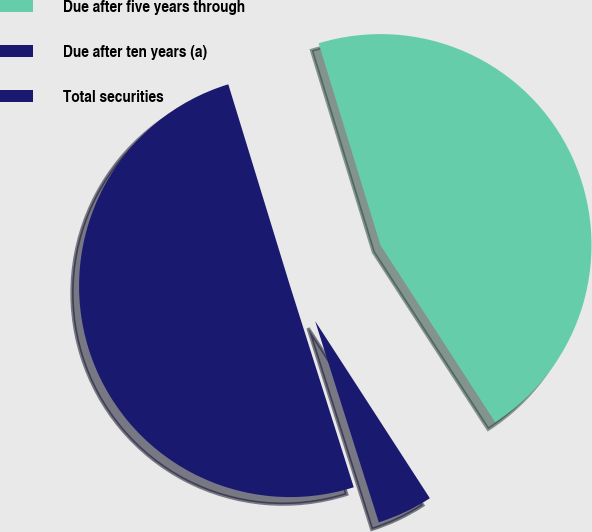<chart> <loc_0><loc_0><loc_500><loc_500><pie_chart><fcel>Due after five years through<fcel>Due after ten years (a)<fcel>Total securities<nl><fcel>45.58%<fcel>4.27%<fcel>50.14%<nl></chart> 